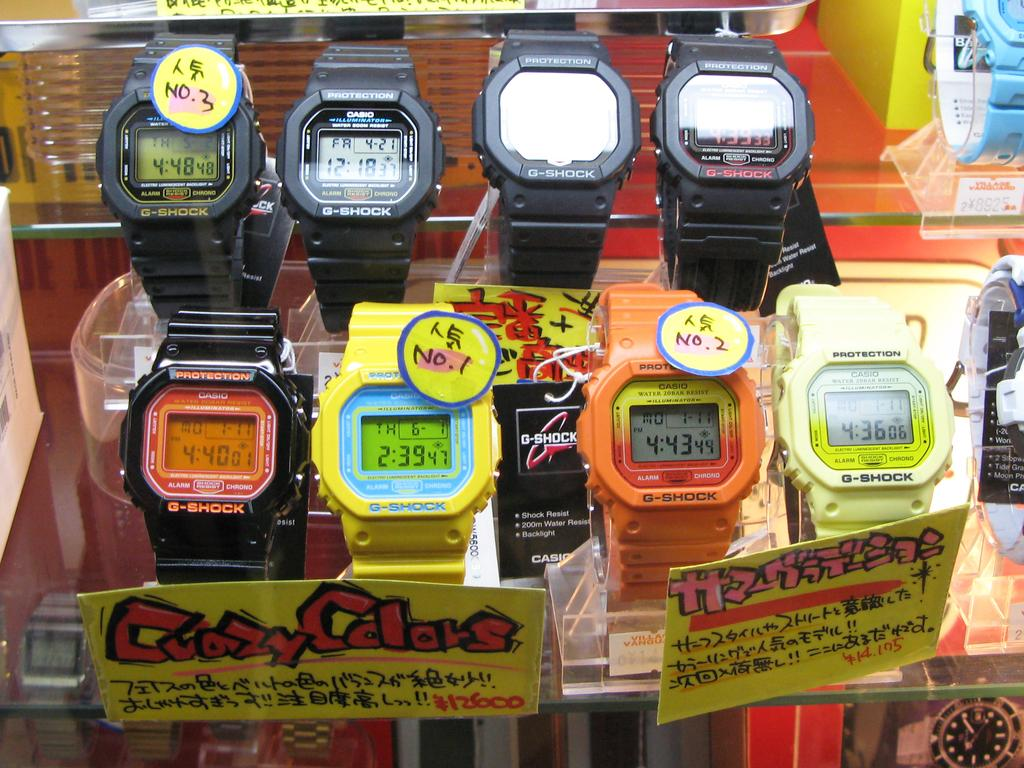<image>
Present a compact description of the photo's key features. Crazy Colors watches are being sold in a store. 